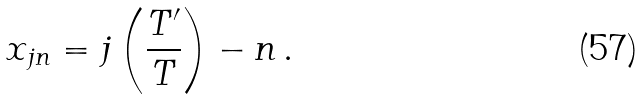<formula> <loc_0><loc_0><loc_500><loc_500>x _ { j n } = j \left ( \frac { T ^ { \prime } } { T } \right ) - n \, .</formula> 